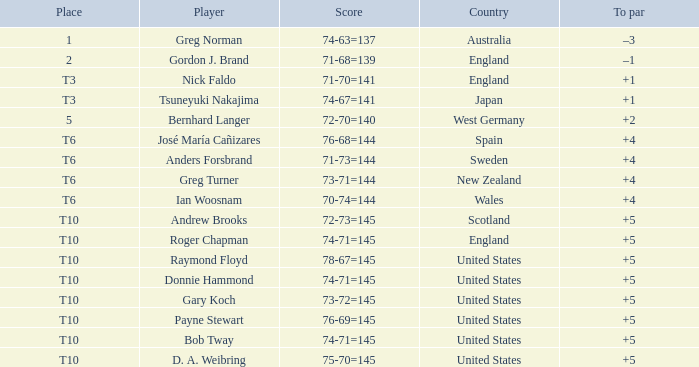Which player scored 76-68=144? José María Cañizares. 